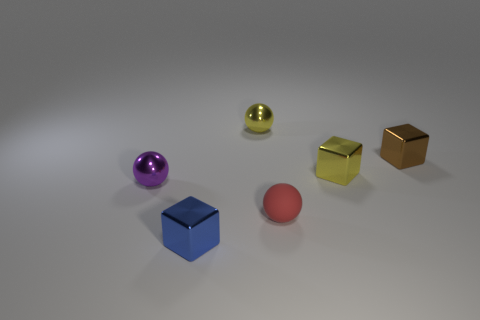The red object is what shape?
Ensure brevity in your answer.  Sphere. What number of large shiny cylinders are there?
Provide a succinct answer. 0. The cube that is in front of the ball to the right of the tiny yellow ball is what color?
Offer a very short reply. Blue. The matte ball that is the same size as the purple thing is what color?
Give a very brief answer. Red. Is there a yellow metal block?
Keep it short and to the point. Yes. What is the shape of the tiny yellow object right of the tiny rubber thing?
Give a very brief answer. Cube. What number of things are to the left of the brown metallic thing and in front of the tiny yellow shiny ball?
Keep it short and to the point. 4. There is a small metal object that is in front of the small purple object; is its shape the same as the yellow shiny thing that is behind the yellow shiny cube?
Give a very brief answer. No. How many things are yellow metal cubes or small things that are left of the small brown metal block?
Make the answer very short. 5. There is a small object that is both in front of the purple metal thing and behind the small blue shiny thing; what is its material?
Your answer should be compact. Rubber. 